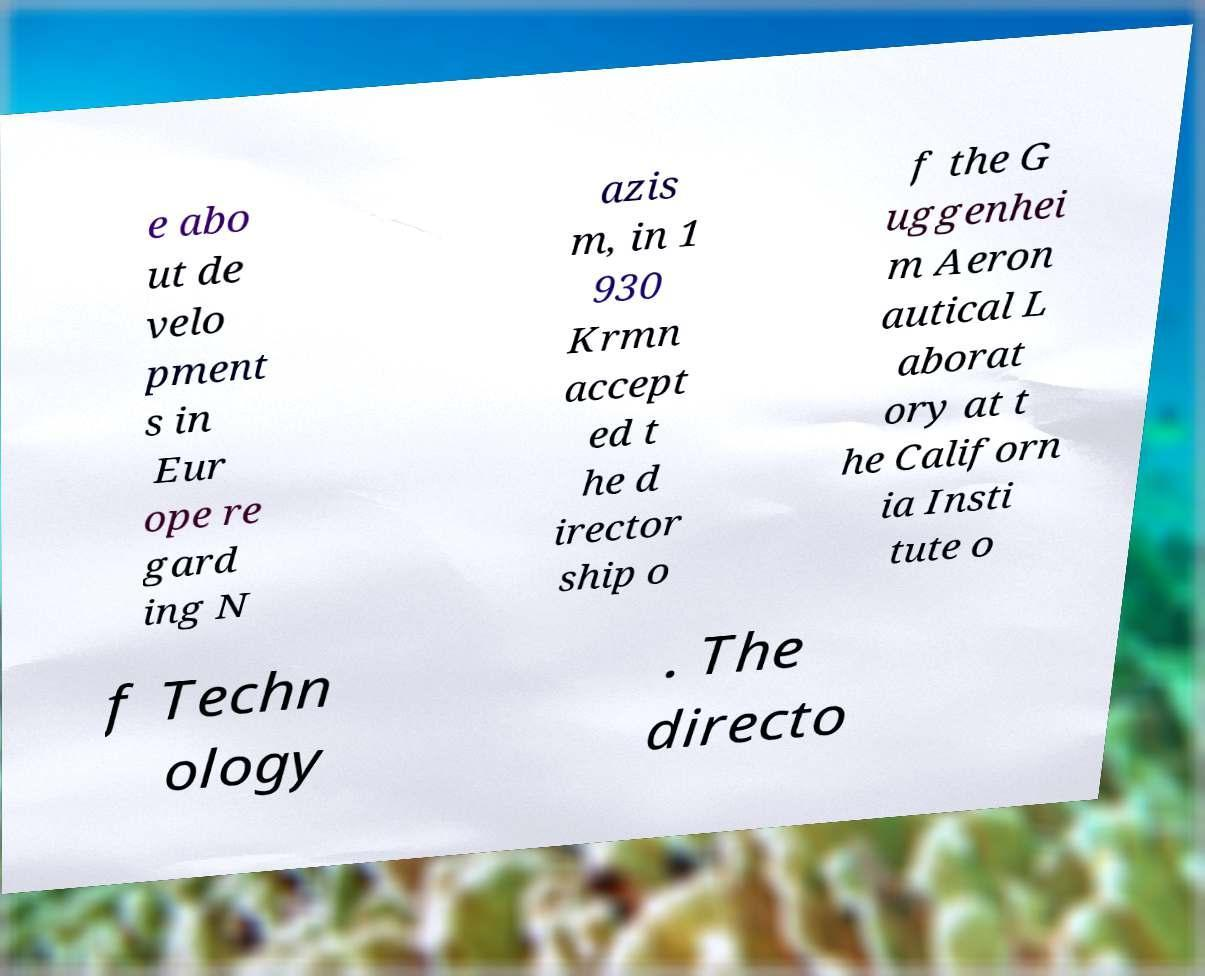What messages or text are displayed in this image? I need them in a readable, typed format. e abo ut de velo pment s in Eur ope re gard ing N azis m, in 1 930 Krmn accept ed t he d irector ship o f the G uggenhei m Aeron autical L aborat ory at t he Californ ia Insti tute o f Techn ology . The directo 